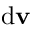Convert formula to latex. <formula><loc_0><loc_0><loc_500><loc_500>{ d } v</formula> 